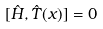<formula> <loc_0><loc_0><loc_500><loc_500>[ \hat { H } , \hat { T } ( x ) ] = 0</formula> 